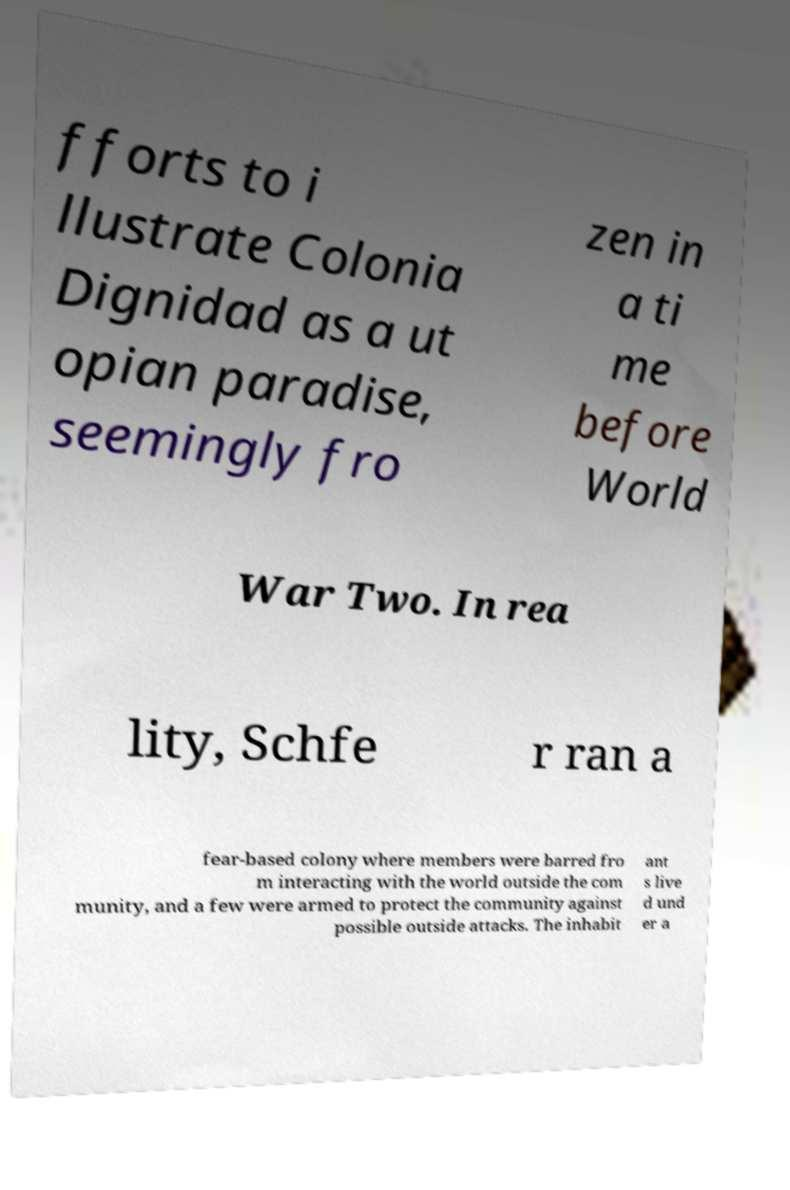Could you assist in decoding the text presented in this image and type it out clearly? fforts to i llustrate Colonia Dignidad as a ut opian paradise, seemingly fro zen in a ti me before World War Two. In rea lity, Schfe r ran a fear-based colony where members were barred fro m interacting with the world outside the com munity, and a few were armed to protect the community against possible outside attacks. The inhabit ant s live d und er a 